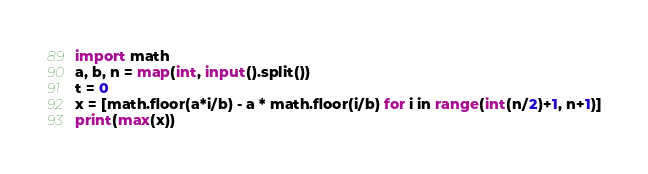Convert code to text. <code><loc_0><loc_0><loc_500><loc_500><_Python_>import math
a, b, n = map(int, input().split())
t = 0
x = [math.floor(a*i/b) - a * math.floor(i/b) for i in range(int(n/2)+1, n+1)]
print(max(x))</code> 